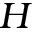Convert formula to latex. <formula><loc_0><loc_0><loc_500><loc_500>H</formula> 